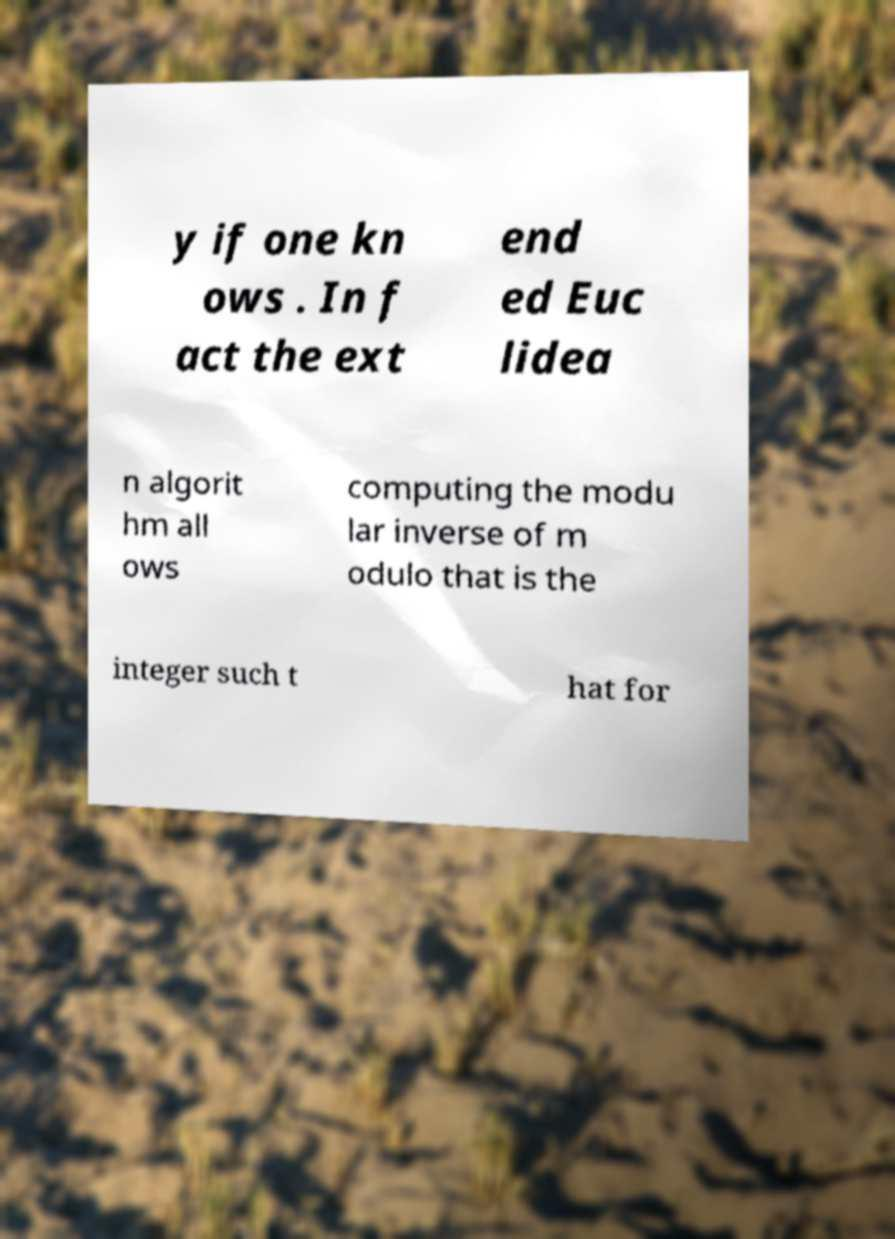Could you assist in decoding the text presented in this image and type it out clearly? y if one kn ows . In f act the ext end ed Euc lidea n algorit hm all ows computing the modu lar inverse of m odulo that is the integer such t hat for 